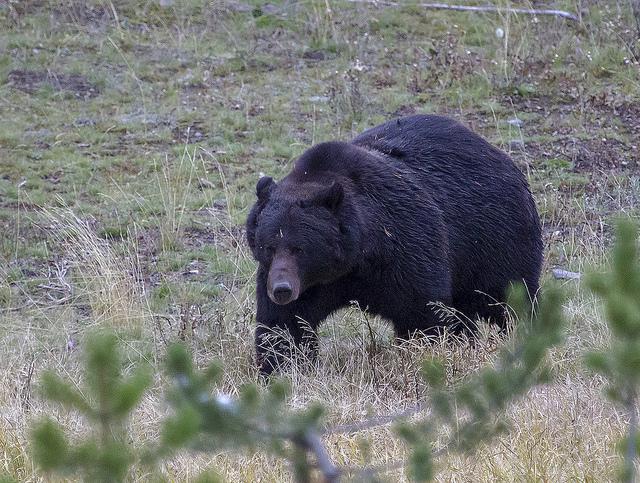Where does this bear live?
Give a very brief answer. Wild. What color is the bear's nose?
Write a very short answer. Black. How many bears are there?
Short answer required. 1. Is this a forest?
Short answer required. No. What is the bear doing?
Short answer required. Walking. What color is the grass?
Give a very brief answer. Green. What is the bear smelling?
Concise answer only. Grass. 